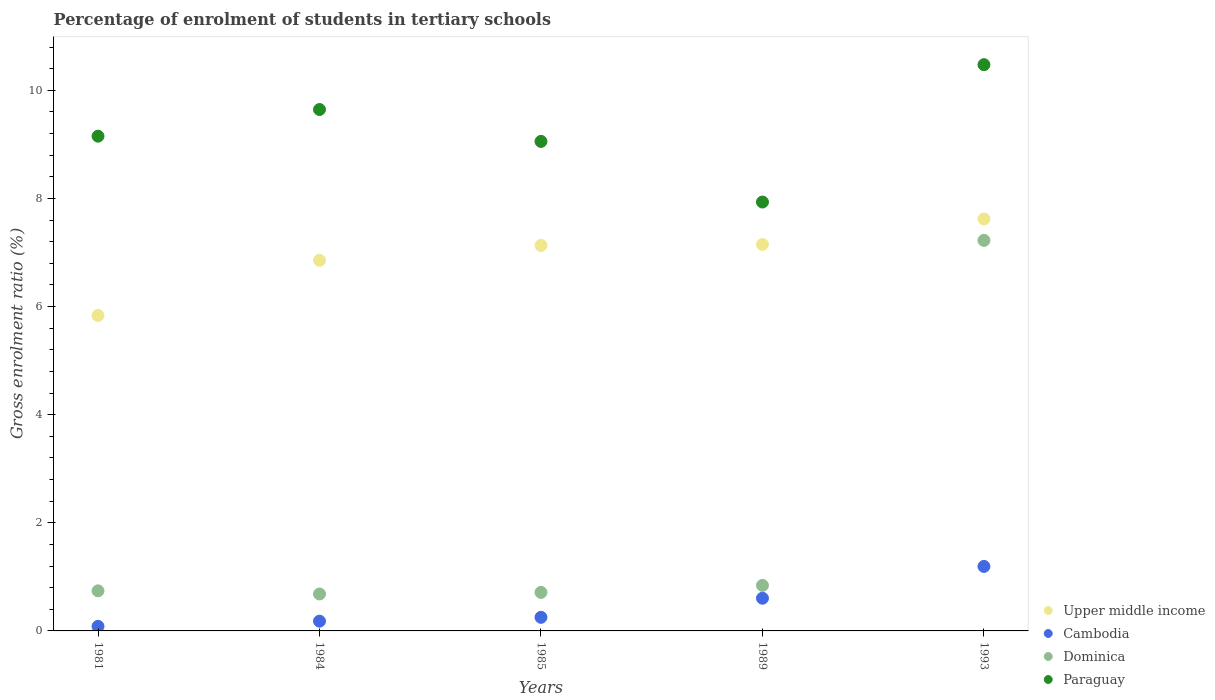How many different coloured dotlines are there?
Offer a very short reply. 4. What is the percentage of students enrolled in tertiary schools in Upper middle income in 1984?
Keep it short and to the point. 6.86. Across all years, what is the maximum percentage of students enrolled in tertiary schools in Upper middle income?
Provide a short and direct response. 7.62. Across all years, what is the minimum percentage of students enrolled in tertiary schools in Upper middle income?
Ensure brevity in your answer.  5.84. In which year was the percentage of students enrolled in tertiary schools in Dominica maximum?
Make the answer very short. 1993. In which year was the percentage of students enrolled in tertiary schools in Dominica minimum?
Your response must be concise. 1984. What is the total percentage of students enrolled in tertiary schools in Dominica in the graph?
Your response must be concise. 10.2. What is the difference between the percentage of students enrolled in tertiary schools in Cambodia in 1985 and that in 1989?
Keep it short and to the point. -0.35. What is the difference between the percentage of students enrolled in tertiary schools in Upper middle income in 1993 and the percentage of students enrolled in tertiary schools in Paraguay in 1985?
Keep it short and to the point. -1.43. What is the average percentage of students enrolled in tertiary schools in Cambodia per year?
Your answer should be very brief. 0.46. In the year 1985, what is the difference between the percentage of students enrolled in tertiary schools in Cambodia and percentage of students enrolled in tertiary schools in Dominica?
Ensure brevity in your answer.  -0.46. What is the ratio of the percentage of students enrolled in tertiary schools in Upper middle income in 1981 to that in 1985?
Your answer should be compact. 0.82. What is the difference between the highest and the second highest percentage of students enrolled in tertiary schools in Paraguay?
Make the answer very short. 0.83. What is the difference between the highest and the lowest percentage of students enrolled in tertiary schools in Upper middle income?
Make the answer very short. 1.79. Is the sum of the percentage of students enrolled in tertiary schools in Dominica in 1981 and 1989 greater than the maximum percentage of students enrolled in tertiary schools in Paraguay across all years?
Provide a succinct answer. No. Does the percentage of students enrolled in tertiary schools in Upper middle income monotonically increase over the years?
Offer a terse response. Yes. Is the percentage of students enrolled in tertiary schools in Upper middle income strictly greater than the percentage of students enrolled in tertiary schools in Cambodia over the years?
Give a very brief answer. Yes. How many dotlines are there?
Make the answer very short. 4. Does the graph contain any zero values?
Provide a succinct answer. No. Does the graph contain grids?
Your answer should be very brief. No. How many legend labels are there?
Ensure brevity in your answer.  4. How are the legend labels stacked?
Make the answer very short. Vertical. What is the title of the graph?
Your answer should be compact. Percentage of enrolment of students in tertiary schools. What is the label or title of the Y-axis?
Keep it short and to the point. Gross enrolment ratio (%). What is the Gross enrolment ratio (%) of Upper middle income in 1981?
Your response must be concise. 5.84. What is the Gross enrolment ratio (%) of Cambodia in 1981?
Ensure brevity in your answer.  0.08. What is the Gross enrolment ratio (%) in Dominica in 1981?
Provide a succinct answer. 0.74. What is the Gross enrolment ratio (%) in Paraguay in 1981?
Give a very brief answer. 9.15. What is the Gross enrolment ratio (%) in Upper middle income in 1984?
Give a very brief answer. 6.86. What is the Gross enrolment ratio (%) in Cambodia in 1984?
Ensure brevity in your answer.  0.18. What is the Gross enrolment ratio (%) of Dominica in 1984?
Offer a terse response. 0.68. What is the Gross enrolment ratio (%) of Paraguay in 1984?
Provide a short and direct response. 9.65. What is the Gross enrolment ratio (%) of Upper middle income in 1985?
Provide a short and direct response. 7.13. What is the Gross enrolment ratio (%) in Cambodia in 1985?
Provide a succinct answer. 0.25. What is the Gross enrolment ratio (%) in Dominica in 1985?
Give a very brief answer. 0.71. What is the Gross enrolment ratio (%) of Paraguay in 1985?
Your answer should be very brief. 9.06. What is the Gross enrolment ratio (%) of Upper middle income in 1989?
Offer a terse response. 7.15. What is the Gross enrolment ratio (%) of Cambodia in 1989?
Your answer should be very brief. 0.6. What is the Gross enrolment ratio (%) in Dominica in 1989?
Give a very brief answer. 0.84. What is the Gross enrolment ratio (%) of Paraguay in 1989?
Make the answer very short. 7.93. What is the Gross enrolment ratio (%) of Upper middle income in 1993?
Make the answer very short. 7.62. What is the Gross enrolment ratio (%) of Cambodia in 1993?
Provide a short and direct response. 1.19. What is the Gross enrolment ratio (%) of Dominica in 1993?
Your answer should be compact. 7.22. What is the Gross enrolment ratio (%) of Paraguay in 1993?
Keep it short and to the point. 10.48. Across all years, what is the maximum Gross enrolment ratio (%) in Upper middle income?
Your answer should be very brief. 7.62. Across all years, what is the maximum Gross enrolment ratio (%) of Cambodia?
Provide a short and direct response. 1.19. Across all years, what is the maximum Gross enrolment ratio (%) in Dominica?
Make the answer very short. 7.22. Across all years, what is the maximum Gross enrolment ratio (%) in Paraguay?
Offer a terse response. 10.48. Across all years, what is the minimum Gross enrolment ratio (%) of Upper middle income?
Provide a succinct answer. 5.84. Across all years, what is the minimum Gross enrolment ratio (%) in Cambodia?
Provide a short and direct response. 0.08. Across all years, what is the minimum Gross enrolment ratio (%) in Dominica?
Provide a short and direct response. 0.68. Across all years, what is the minimum Gross enrolment ratio (%) of Paraguay?
Offer a terse response. 7.93. What is the total Gross enrolment ratio (%) of Upper middle income in the graph?
Provide a succinct answer. 34.6. What is the total Gross enrolment ratio (%) in Cambodia in the graph?
Provide a short and direct response. 2.31. What is the total Gross enrolment ratio (%) in Dominica in the graph?
Offer a terse response. 10.2. What is the total Gross enrolment ratio (%) in Paraguay in the graph?
Make the answer very short. 46.26. What is the difference between the Gross enrolment ratio (%) in Upper middle income in 1981 and that in 1984?
Ensure brevity in your answer.  -1.02. What is the difference between the Gross enrolment ratio (%) of Cambodia in 1981 and that in 1984?
Offer a very short reply. -0.1. What is the difference between the Gross enrolment ratio (%) in Dominica in 1981 and that in 1984?
Offer a terse response. 0.06. What is the difference between the Gross enrolment ratio (%) in Paraguay in 1981 and that in 1984?
Give a very brief answer. -0.49. What is the difference between the Gross enrolment ratio (%) of Upper middle income in 1981 and that in 1985?
Give a very brief answer. -1.3. What is the difference between the Gross enrolment ratio (%) in Cambodia in 1981 and that in 1985?
Ensure brevity in your answer.  -0.17. What is the difference between the Gross enrolment ratio (%) in Dominica in 1981 and that in 1985?
Offer a terse response. 0.03. What is the difference between the Gross enrolment ratio (%) in Paraguay in 1981 and that in 1985?
Your answer should be very brief. 0.1. What is the difference between the Gross enrolment ratio (%) of Upper middle income in 1981 and that in 1989?
Your answer should be compact. -1.31. What is the difference between the Gross enrolment ratio (%) of Cambodia in 1981 and that in 1989?
Offer a terse response. -0.52. What is the difference between the Gross enrolment ratio (%) of Dominica in 1981 and that in 1989?
Give a very brief answer. -0.1. What is the difference between the Gross enrolment ratio (%) in Paraguay in 1981 and that in 1989?
Your response must be concise. 1.22. What is the difference between the Gross enrolment ratio (%) in Upper middle income in 1981 and that in 1993?
Make the answer very short. -1.79. What is the difference between the Gross enrolment ratio (%) in Cambodia in 1981 and that in 1993?
Ensure brevity in your answer.  -1.11. What is the difference between the Gross enrolment ratio (%) of Dominica in 1981 and that in 1993?
Give a very brief answer. -6.48. What is the difference between the Gross enrolment ratio (%) in Paraguay in 1981 and that in 1993?
Your answer should be compact. -1.32. What is the difference between the Gross enrolment ratio (%) in Upper middle income in 1984 and that in 1985?
Ensure brevity in your answer.  -0.27. What is the difference between the Gross enrolment ratio (%) of Cambodia in 1984 and that in 1985?
Provide a short and direct response. -0.07. What is the difference between the Gross enrolment ratio (%) of Dominica in 1984 and that in 1985?
Ensure brevity in your answer.  -0.03. What is the difference between the Gross enrolment ratio (%) of Paraguay in 1984 and that in 1985?
Offer a terse response. 0.59. What is the difference between the Gross enrolment ratio (%) of Upper middle income in 1984 and that in 1989?
Provide a succinct answer. -0.29. What is the difference between the Gross enrolment ratio (%) in Cambodia in 1984 and that in 1989?
Make the answer very short. -0.42. What is the difference between the Gross enrolment ratio (%) of Dominica in 1984 and that in 1989?
Keep it short and to the point. -0.16. What is the difference between the Gross enrolment ratio (%) in Paraguay in 1984 and that in 1989?
Provide a succinct answer. 1.71. What is the difference between the Gross enrolment ratio (%) in Upper middle income in 1984 and that in 1993?
Your answer should be very brief. -0.76. What is the difference between the Gross enrolment ratio (%) of Cambodia in 1984 and that in 1993?
Ensure brevity in your answer.  -1.01. What is the difference between the Gross enrolment ratio (%) of Dominica in 1984 and that in 1993?
Ensure brevity in your answer.  -6.54. What is the difference between the Gross enrolment ratio (%) of Paraguay in 1984 and that in 1993?
Provide a succinct answer. -0.83. What is the difference between the Gross enrolment ratio (%) in Upper middle income in 1985 and that in 1989?
Provide a short and direct response. -0.02. What is the difference between the Gross enrolment ratio (%) of Cambodia in 1985 and that in 1989?
Your answer should be compact. -0.35. What is the difference between the Gross enrolment ratio (%) of Dominica in 1985 and that in 1989?
Your response must be concise. -0.13. What is the difference between the Gross enrolment ratio (%) of Paraguay in 1985 and that in 1989?
Keep it short and to the point. 1.12. What is the difference between the Gross enrolment ratio (%) of Upper middle income in 1985 and that in 1993?
Give a very brief answer. -0.49. What is the difference between the Gross enrolment ratio (%) of Cambodia in 1985 and that in 1993?
Ensure brevity in your answer.  -0.94. What is the difference between the Gross enrolment ratio (%) in Dominica in 1985 and that in 1993?
Ensure brevity in your answer.  -6.51. What is the difference between the Gross enrolment ratio (%) in Paraguay in 1985 and that in 1993?
Your answer should be very brief. -1.42. What is the difference between the Gross enrolment ratio (%) in Upper middle income in 1989 and that in 1993?
Make the answer very short. -0.47. What is the difference between the Gross enrolment ratio (%) in Cambodia in 1989 and that in 1993?
Your answer should be very brief. -0.59. What is the difference between the Gross enrolment ratio (%) of Dominica in 1989 and that in 1993?
Make the answer very short. -6.38. What is the difference between the Gross enrolment ratio (%) of Paraguay in 1989 and that in 1993?
Provide a succinct answer. -2.54. What is the difference between the Gross enrolment ratio (%) of Upper middle income in 1981 and the Gross enrolment ratio (%) of Cambodia in 1984?
Provide a short and direct response. 5.66. What is the difference between the Gross enrolment ratio (%) of Upper middle income in 1981 and the Gross enrolment ratio (%) of Dominica in 1984?
Your response must be concise. 5.15. What is the difference between the Gross enrolment ratio (%) of Upper middle income in 1981 and the Gross enrolment ratio (%) of Paraguay in 1984?
Keep it short and to the point. -3.81. What is the difference between the Gross enrolment ratio (%) in Cambodia in 1981 and the Gross enrolment ratio (%) in Dominica in 1984?
Provide a short and direct response. -0.6. What is the difference between the Gross enrolment ratio (%) in Cambodia in 1981 and the Gross enrolment ratio (%) in Paraguay in 1984?
Ensure brevity in your answer.  -9.56. What is the difference between the Gross enrolment ratio (%) of Dominica in 1981 and the Gross enrolment ratio (%) of Paraguay in 1984?
Your answer should be very brief. -8.9. What is the difference between the Gross enrolment ratio (%) in Upper middle income in 1981 and the Gross enrolment ratio (%) in Cambodia in 1985?
Your answer should be very brief. 5.58. What is the difference between the Gross enrolment ratio (%) of Upper middle income in 1981 and the Gross enrolment ratio (%) of Dominica in 1985?
Make the answer very short. 5.12. What is the difference between the Gross enrolment ratio (%) of Upper middle income in 1981 and the Gross enrolment ratio (%) of Paraguay in 1985?
Your answer should be compact. -3.22. What is the difference between the Gross enrolment ratio (%) of Cambodia in 1981 and the Gross enrolment ratio (%) of Dominica in 1985?
Give a very brief answer. -0.63. What is the difference between the Gross enrolment ratio (%) of Cambodia in 1981 and the Gross enrolment ratio (%) of Paraguay in 1985?
Your answer should be very brief. -8.97. What is the difference between the Gross enrolment ratio (%) of Dominica in 1981 and the Gross enrolment ratio (%) of Paraguay in 1985?
Provide a succinct answer. -8.31. What is the difference between the Gross enrolment ratio (%) of Upper middle income in 1981 and the Gross enrolment ratio (%) of Cambodia in 1989?
Your response must be concise. 5.23. What is the difference between the Gross enrolment ratio (%) of Upper middle income in 1981 and the Gross enrolment ratio (%) of Dominica in 1989?
Ensure brevity in your answer.  4.99. What is the difference between the Gross enrolment ratio (%) of Upper middle income in 1981 and the Gross enrolment ratio (%) of Paraguay in 1989?
Your answer should be compact. -2.1. What is the difference between the Gross enrolment ratio (%) of Cambodia in 1981 and the Gross enrolment ratio (%) of Dominica in 1989?
Your answer should be compact. -0.76. What is the difference between the Gross enrolment ratio (%) in Cambodia in 1981 and the Gross enrolment ratio (%) in Paraguay in 1989?
Ensure brevity in your answer.  -7.85. What is the difference between the Gross enrolment ratio (%) in Dominica in 1981 and the Gross enrolment ratio (%) in Paraguay in 1989?
Your answer should be very brief. -7.19. What is the difference between the Gross enrolment ratio (%) of Upper middle income in 1981 and the Gross enrolment ratio (%) of Cambodia in 1993?
Give a very brief answer. 4.64. What is the difference between the Gross enrolment ratio (%) in Upper middle income in 1981 and the Gross enrolment ratio (%) in Dominica in 1993?
Offer a terse response. -1.39. What is the difference between the Gross enrolment ratio (%) of Upper middle income in 1981 and the Gross enrolment ratio (%) of Paraguay in 1993?
Give a very brief answer. -4.64. What is the difference between the Gross enrolment ratio (%) in Cambodia in 1981 and the Gross enrolment ratio (%) in Dominica in 1993?
Provide a short and direct response. -7.14. What is the difference between the Gross enrolment ratio (%) in Cambodia in 1981 and the Gross enrolment ratio (%) in Paraguay in 1993?
Your response must be concise. -10.39. What is the difference between the Gross enrolment ratio (%) in Dominica in 1981 and the Gross enrolment ratio (%) in Paraguay in 1993?
Offer a terse response. -9.73. What is the difference between the Gross enrolment ratio (%) of Upper middle income in 1984 and the Gross enrolment ratio (%) of Cambodia in 1985?
Provide a succinct answer. 6.6. What is the difference between the Gross enrolment ratio (%) of Upper middle income in 1984 and the Gross enrolment ratio (%) of Dominica in 1985?
Provide a short and direct response. 6.14. What is the difference between the Gross enrolment ratio (%) in Upper middle income in 1984 and the Gross enrolment ratio (%) in Paraguay in 1985?
Your answer should be very brief. -2.2. What is the difference between the Gross enrolment ratio (%) of Cambodia in 1984 and the Gross enrolment ratio (%) of Dominica in 1985?
Keep it short and to the point. -0.53. What is the difference between the Gross enrolment ratio (%) in Cambodia in 1984 and the Gross enrolment ratio (%) in Paraguay in 1985?
Offer a terse response. -8.88. What is the difference between the Gross enrolment ratio (%) of Dominica in 1984 and the Gross enrolment ratio (%) of Paraguay in 1985?
Provide a short and direct response. -8.37. What is the difference between the Gross enrolment ratio (%) in Upper middle income in 1984 and the Gross enrolment ratio (%) in Cambodia in 1989?
Your answer should be compact. 6.25. What is the difference between the Gross enrolment ratio (%) of Upper middle income in 1984 and the Gross enrolment ratio (%) of Dominica in 1989?
Make the answer very short. 6.01. What is the difference between the Gross enrolment ratio (%) of Upper middle income in 1984 and the Gross enrolment ratio (%) of Paraguay in 1989?
Ensure brevity in your answer.  -1.08. What is the difference between the Gross enrolment ratio (%) of Cambodia in 1984 and the Gross enrolment ratio (%) of Dominica in 1989?
Ensure brevity in your answer.  -0.66. What is the difference between the Gross enrolment ratio (%) of Cambodia in 1984 and the Gross enrolment ratio (%) of Paraguay in 1989?
Keep it short and to the point. -7.75. What is the difference between the Gross enrolment ratio (%) of Dominica in 1984 and the Gross enrolment ratio (%) of Paraguay in 1989?
Keep it short and to the point. -7.25. What is the difference between the Gross enrolment ratio (%) of Upper middle income in 1984 and the Gross enrolment ratio (%) of Cambodia in 1993?
Provide a succinct answer. 5.66. What is the difference between the Gross enrolment ratio (%) of Upper middle income in 1984 and the Gross enrolment ratio (%) of Dominica in 1993?
Your answer should be compact. -0.37. What is the difference between the Gross enrolment ratio (%) of Upper middle income in 1984 and the Gross enrolment ratio (%) of Paraguay in 1993?
Offer a terse response. -3.62. What is the difference between the Gross enrolment ratio (%) of Cambodia in 1984 and the Gross enrolment ratio (%) of Dominica in 1993?
Provide a short and direct response. -7.04. What is the difference between the Gross enrolment ratio (%) in Cambodia in 1984 and the Gross enrolment ratio (%) in Paraguay in 1993?
Provide a succinct answer. -10.3. What is the difference between the Gross enrolment ratio (%) of Dominica in 1984 and the Gross enrolment ratio (%) of Paraguay in 1993?
Keep it short and to the point. -9.79. What is the difference between the Gross enrolment ratio (%) of Upper middle income in 1985 and the Gross enrolment ratio (%) of Cambodia in 1989?
Provide a short and direct response. 6.53. What is the difference between the Gross enrolment ratio (%) of Upper middle income in 1985 and the Gross enrolment ratio (%) of Dominica in 1989?
Keep it short and to the point. 6.29. What is the difference between the Gross enrolment ratio (%) in Upper middle income in 1985 and the Gross enrolment ratio (%) in Paraguay in 1989?
Your answer should be very brief. -0.8. What is the difference between the Gross enrolment ratio (%) in Cambodia in 1985 and the Gross enrolment ratio (%) in Dominica in 1989?
Offer a very short reply. -0.59. What is the difference between the Gross enrolment ratio (%) in Cambodia in 1985 and the Gross enrolment ratio (%) in Paraguay in 1989?
Make the answer very short. -7.68. What is the difference between the Gross enrolment ratio (%) of Dominica in 1985 and the Gross enrolment ratio (%) of Paraguay in 1989?
Ensure brevity in your answer.  -7.22. What is the difference between the Gross enrolment ratio (%) in Upper middle income in 1985 and the Gross enrolment ratio (%) in Cambodia in 1993?
Offer a very short reply. 5.94. What is the difference between the Gross enrolment ratio (%) in Upper middle income in 1985 and the Gross enrolment ratio (%) in Dominica in 1993?
Your answer should be very brief. -0.09. What is the difference between the Gross enrolment ratio (%) in Upper middle income in 1985 and the Gross enrolment ratio (%) in Paraguay in 1993?
Your answer should be very brief. -3.34. What is the difference between the Gross enrolment ratio (%) in Cambodia in 1985 and the Gross enrolment ratio (%) in Dominica in 1993?
Your answer should be very brief. -6.97. What is the difference between the Gross enrolment ratio (%) of Cambodia in 1985 and the Gross enrolment ratio (%) of Paraguay in 1993?
Provide a short and direct response. -10.22. What is the difference between the Gross enrolment ratio (%) in Dominica in 1985 and the Gross enrolment ratio (%) in Paraguay in 1993?
Make the answer very short. -9.76. What is the difference between the Gross enrolment ratio (%) in Upper middle income in 1989 and the Gross enrolment ratio (%) in Cambodia in 1993?
Give a very brief answer. 5.96. What is the difference between the Gross enrolment ratio (%) in Upper middle income in 1989 and the Gross enrolment ratio (%) in Dominica in 1993?
Give a very brief answer. -0.07. What is the difference between the Gross enrolment ratio (%) in Upper middle income in 1989 and the Gross enrolment ratio (%) in Paraguay in 1993?
Give a very brief answer. -3.33. What is the difference between the Gross enrolment ratio (%) of Cambodia in 1989 and the Gross enrolment ratio (%) of Dominica in 1993?
Give a very brief answer. -6.62. What is the difference between the Gross enrolment ratio (%) in Cambodia in 1989 and the Gross enrolment ratio (%) in Paraguay in 1993?
Provide a short and direct response. -9.87. What is the difference between the Gross enrolment ratio (%) of Dominica in 1989 and the Gross enrolment ratio (%) of Paraguay in 1993?
Provide a succinct answer. -9.63. What is the average Gross enrolment ratio (%) in Upper middle income per year?
Offer a very short reply. 6.92. What is the average Gross enrolment ratio (%) of Cambodia per year?
Your answer should be very brief. 0.46. What is the average Gross enrolment ratio (%) in Dominica per year?
Provide a short and direct response. 2.04. What is the average Gross enrolment ratio (%) of Paraguay per year?
Provide a short and direct response. 9.25. In the year 1981, what is the difference between the Gross enrolment ratio (%) in Upper middle income and Gross enrolment ratio (%) in Cambodia?
Provide a succinct answer. 5.75. In the year 1981, what is the difference between the Gross enrolment ratio (%) of Upper middle income and Gross enrolment ratio (%) of Dominica?
Ensure brevity in your answer.  5.09. In the year 1981, what is the difference between the Gross enrolment ratio (%) in Upper middle income and Gross enrolment ratio (%) in Paraguay?
Offer a terse response. -3.32. In the year 1981, what is the difference between the Gross enrolment ratio (%) of Cambodia and Gross enrolment ratio (%) of Dominica?
Your answer should be compact. -0.66. In the year 1981, what is the difference between the Gross enrolment ratio (%) in Cambodia and Gross enrolment ratio (%) in Paraguay?
Ensure brevity in your answer.  -9.07. In the year 1981, what is the difference between the Gross enrolment ratio (%) of Dominica and Gross enrolment ratio (%) of Paraguay?
Offer a very short reply. -8.41. In the year 1984, what is the difference between the Gross enrolment ratio (%) of Upper middle income and Gross enrolment ratio (%) of Cambodia?
Offer a terse response. 6.68. In the year 1984, what is the difference between the Gross enrolment ratio (%) in Upper middle income and Gross enrolment ratio (%) in Dominica?
Provide a short and direct response. 6.17. In the year 1984, what is the difference between the Gross enrolment ratio (%) in Upper middle income and Gross enrolment ratio (%) in Paraguay?
Provide a short and direct response. -2.79. In the year 1984, what is the difference between the Gross enrolment ratio (%) of Cambodia and Gross enrolment ratio (%) of Dominica?
Provide a short and direct response. -0.5. In the year 1984, what is the difference between the Gross enrolment ratio (%) in Cambodia and Gross enrolment ratio (%) in Paraguay?
Keep it short and to the point. -9.47. In the year 1984, what is the difference between the Gross enrolment ratio (%) in Dominica and Gross enrolment ratio (%) in Paraguay?
Provide a short and direct response. -8.96. In the year 1985, what is the difference between the Gross enrolment ratio (%) in Upper middle income and Gross enrolment ratio (%) in Cambodia?
Make the answer very short. 6.88. In the year 1985, what is the difference between the Gross enrolment ratio (%) of Upper middle income and Gross enrolment ratio (%) of Dominica?
Give a very brief answer. 6.42. In the year 1985, what is the difference between the Gross enrolment ratio (%) in Upper middle income and Gross enrolment ratio (%) in Paraguay?
Ensure brevity in your answer.  -1.92. In the year 1985, what is the difference between the Gross enrolment ratio (%) in Cambodia and Gross enrolment ratio (%) in Dominica?
Your answer should be very brief. -0.46. In the year 1985, what is the difference between the Gross enrolment ratio (%) in Cambodia and Gross enrolment ratio (%) in Paraguay?
Offer a very short reply. -8.8. In the year 1985, what is the difference between the Gross enrolment ratio (%) of Dominica and Gross enrolment ratio (%) of Paraguay?
Provide a short and direct response. -8.34. In the year 1989, what is the difference between the Gross enrolment ratio (%) of Upper middle income and Gross enrolment ratio (%) of Cambodia?
Provide a short and direct response. 6.55. In the year 1989, what is the difference between the Gross enrolment ratio (%) in Upper middle income and Gross enrolment ratio (%) in Dominica?
Your response must be concise. 6.31. In the year 1989, what is the difference between the Gross enrolment ratio (%) in Upper middle income and Gross enrolment ratio (%) in Paraguay?
Your answer should be compact. -0.78. In the year 1989, what is the difference between the Gross enrolment ratio (%) in Cambodia and Gross enrolment ratio (%) in Dominica?
Keep it short and to the point. -0.24. In the year 1989, what is the difference between the Gross enrolment ratio (%) of Cambodia and Gross enrolment ratio (%) of Paraguay?
Provide a short and direct response. -7.33. In the year 1989, what is the difference between the Gross enrolment ratio (%) in Dominica and Gross enrolment ratio (%) in Paraguay?
Offer a terse response. -7.09. In the year 1993, what is the difference between the Gross enrolment ratio (%) in Upper middle income and Gross enrolment ratio (%) in Cambodia?
Give a very brief answer. 6.43. In the year 1993, what is the difference between the Gross enrolment ratio (%) in Upper middle income and Gross enrolment ratio (%) in Dominica?
Ensure brevity in your answer.  0.4. In the year 1993, what is the difference between the Gross enrolment ratio (%) in Upper middle income and Gross enrolment ratio (%) in Paraguay?
Ensure brevity in your answer.  -2.85. In the year 1993, what is the difference between the Gross enrolment ratio (%) of Cambodia and Gross enrolment ratio (%) of Dominica?
Offer a terse response. -6.03. In the year 1993, what is the difference between the Gross enrolment ratio (%) in Cambodia and Gross enrolment ratio (%) in Paraguay?
Provide a short and direct response. -9.28. In the year 1993, what is the difference between the Gross enrolment ratio (%) of Dominica and Gross enrolment ratio (%) of Paraguay?
Your response must be concise. -3.25. What is the ratio of the Gross enrolment ratio (%) of Upper middle income in 1981 to that in 1984?
Offer a terse response. 0.85. What is the ratio of the Gross enrolment ratio (%) of Cambodia in 1981 to that in 1984?
Provide a succinct answer. 0.47. What is the ratio of the Gross enrolment ratio (%) of Dominica in 1981 to that in 1984?
Give a very brief answer. 1.09. What is the ratio of the Gross enrolment ratio (%) in Paraguay in 1981 to that in 1984?
Your response must be concise. 0.95. What is the ratio of the Gross enrolment ratio (%) in Upper middle income in 1981 to that in 1985?
Ensure brevity in your answer.  0.82. What is the ratio of the Gross enrolment ratio (%) of Cambodia in 1981 to that in 1985?
Provide a succinct answer. 0.34. What is the ratio of the Gross enrolment ratio (%) in Dominica in 1981 to that in 1985?
Your response must be concise. 1.04. What is the ratio of the Gross enrolment ratio (%) of Paraguay in 1981 to that in 1985?
Offer a very short reply. 1.01. What is the ratio of the Gross enrolment ratio (%) of Upper middle income in 1981 to that in 1989?
Provide a succinct answer. 0.82. What is the ratio of the Gross enrolment ratio (%) in Cambodia in 1981 to that in 1989?
Ensure brevity in your answer.  0.14. What is the ratio of the Gross enrolment ratio (%) in Dominica in 1981 to that in 1989?
Your answer should be very brief. 0.88. What is the ratio of the Gross enrolment ratio (%) of Paraguay in 1981 to that in 1989?
Offer a very short reply. 1.15. What is the ratio of the Gross enrolment ratio (%) of Upper middle income in 1981 to that in 1993?
Offer a terse response. 0.77. What is the ratio of the Gross enrolment ratio (%) in Cambodia in 1981 to that in 1993?
Your response must be concise. 0.07. What is the ratio of the Gross enrolment ratio (%) of Dominica in 1981 to that in 1993?
Your response must be concise. 0.1. What is the ratio of the Gross enrolment ratio (%) of Paraguay in 1981 to that in 1993?
Your answer should be compact. 0.87. What is the ratio of the Gross enrolment ratio (%) in Upper middle income in 1984 to that in 1985?
Ensure brevity in your answer.  0.96. What is the ratio of the Gross enrolment ratio (%) in Cambodia in 1984 to that in 1985?
Your answer should be compact. 0.72. What is the ratio of the Gross enrolment ratio (%) in Dominica in 1984 to that in 1985?
Your answer should be very brief. 0.96. What is the ratio of the Gross enrolment ratio (%) of Paraguay in 1984 to that in 1985?
Make the answer very short. 1.07. What is the ratio of the Gross enrolment ratio (%) of Cambodia in 1984 to that in 1989?
Offer a terse response. 0.3. What is the ratio of the Gross enrolment ratio (%) in Dominica in 1984 to that in 1989?
Give a very brief answer. 0.81. What is the ratio of the Gross enrolment ratio (%) in Paraguay in 1984 to that in 1989?
Your response must be concise. 1.22. What is the ratio of the Gross enrolment ratio (%) in Upper middle income in 1984 to that in 1993?
Your response must be concise. 0.9. What is the ratio of the Gross enrolment ratio (%) of Cambodia in 1984 to that in 1993?
Your answer should be compact. 0.15. What is the ratio of the Gross enrolment ratio (%) of Dominica in 1984 to that in 1993?
Give a very brief answer. 0.09. What is the ratio of the Gross enrolment ratio (%) of Paraguay in 1984 to that in 1993?
Give a very brief answer. 0.92. What is the ratio of the Gross enrolment ratio (%) in Cambodia in 1985 to that in 1989?
Offer a terse response. 0.42. What is the ratio of the Gross enrolment ratio (%) in Dominica in 1985 to that in 1989?
Your answer should be very brief. 0.85. What is the ratio of the Gross enrolment ratio (%) in Paraguay in 1985 to that in 1989?
Give a very brief answer. 1.14. What is the ratio of the Gross enrolment ratio (%) of Upper middle income in 1985 to that in 1993?
Your answer should be compact. 0.94. What is the ratio of the Gross enrolment ratio (%) of Cambodia in 1985 to that in 1993?
Your answer should be very brief. 0.21. What is the ratio of the Gross enrolment ratio (%) of Dominica in 1985 to that in 1993?
Give a very brief answer. 0.1. What is the ratio of the Gross enrolment ratio (%) of Paraguay in 1985 to that in 1993?
Provide a succinct answer. 0.86. What is the ratio of the Gross enrolment ratio (%) of Upper middle income in 1989 to that in 1993?
Your response must be concise. 0.94. What is the ratio of the Gross enrolment ratio (%) in Cambodia in 1989 to that in 1993?
Offer a very short reply. 0.51. What is the ratio of the Gross enrolment ratio (%) in Dominica in 1989 to that in 1993?
Offer a very short reply. 0.12. What is the ratio of the Gross enrolment ratio (%) of Paraguay in 1989 to that in 1993?
Offer a very short reply. 0.76. What is the difference between the highest and the second highest Gross enrolment ratio (%) of Upper middle income?
Your answer should be compact. 0.47. What is the difference between the highest and the second highest Gross enrolment ratio (%) in Cambodia?
Provide a short and direct response. 0.59. What is the difference between the highest and the second highest Gross enrolment ratio (%) of Dominica?
Ensure brevity in your answer.  6.38. What is the difference between the highest and the second highest Gross enrolment ratio (%) of Paraguay?
Your answer should be very brief. 0.83. What is the difference between the highest and the lowest Gross enrolment ratio (%) in Upper middle income?
Your response must be concise. 1.79. What is the difference between the highest and the lowest Gross enrolment ratio (%) in Cambodia?
Your response must be concise. 1.11. What is the difference between the highest and the lowest Gross enrolment ratio (%) in Dominica?
Offer a very short reply. 6.54. What is the difference between the highest and the lowest Gross enrolment ratio (%) in Paraguay?
Ensure brevity in your answer.  2.54. 